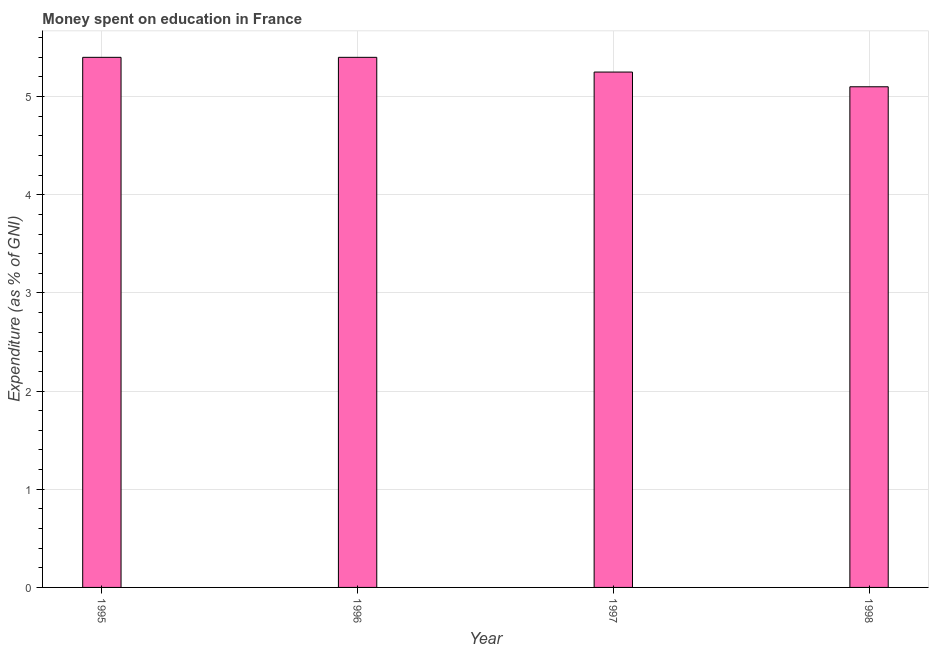Does the graph contain any zero values?
Give a very brief answer. No. Does the graph contain grids?
Provide a short and direct response. Yes. What is the title of the graph?
Make the answer very short. Money spent on education in France. What is the label or title of the Y-axis?
Offer a very short reply. Expenditure (as % of GNI). What is the expenditure on education in 1995?
Provide a short and direct response. 5.4. In which year was the expenditure on education maximum?
Your response must be concise. 1995. In which year was the expenditure on education minimum?
Provide a short and direct response. 1998. What is the sum of the expenditure on education?
Keep it short and to the point. 21.15. What is the average expenditure on education per year?
Keep it short and to the point. 5.29. What is the median expenditure on education?
Provide a succinct answer. 5.32. In how many years, is the expenditure on education greater than 2.2 %?
Your answer should be very brief. 4. Is the difference between the expenditure on education in 1995 and 1997 greater than the difference between any two years?
Your answer should be very brief. No. What is the difference between the highest and the lowest expenditure on education?
Provide a short and direct response. 0.3. In how many years, is the expenditure on education greater than the average expenditure on education taken over all years?
Make the answer very short. 2. How many bars are there?
Your response must be concise. 4. How many years are there in the graph?
Offer a terse response. 4. Are the values on the major ticks of Y-axis written in scientific E-notation?
Make the answer very short. No. What is the Expenditure (as % of GNI) in 1995?
Make the answer very short. 5.4. What is the Expenditure (as % of GNI) of 1996?
Ensure brevity in your answer.  5.4. What is the Expenditure (as % of GNI) in 1997?
Make the answer very short. 5.25. What is the difference between the Expenditure (as % of GNI) in 1995 and 1996?
Provide a short and direct response. 0. What is the difference between the Expenditure (as % of GNI) in 1995 and 1997?
Ensure brevity in your answer.  0.15. What is the difference between the Expenditure (as % of GNI) in 1995 and 1998?
Keep it short and to the point. 0.3. What is the difference between the Expenditure (as % of GNI) in 1996 and 1997?
Your answer should be very brief. 0.15. What is the difference between the Expenditure (as % of GNI) in 1997 and 1998?
Give a very brief answer. 0.15. What is the ratio of the Expenditure (as % of GNI) in 1995 to that in 1996?
Provide a short and direct response. 1. What is the ratio of the Expenditure (as % of GNI) in 1995 to that in 1998?
Your answer should be compact. 1.06. What is the ratio of the Expenditure (as % of GNI) in 1996 to that in 1997?
Provide a short and direct response. 1.03. What is the ratio of the Expenditure (as % of GNI) in 1996 to that in 1998?
Provide a succinct answer. 1.06. 